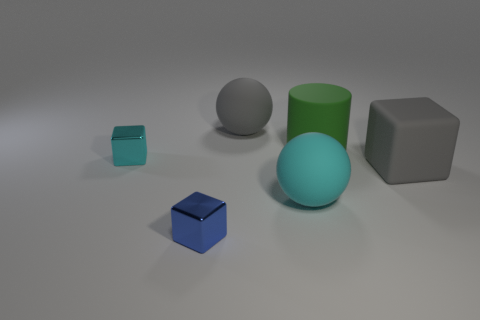Subtract all yellow cylinders. Subtract all red cubes. How many cylinders are left? 1 Subtract all blue cylinders. How many green balls are left? 0 Add 5 large things. How many blues exist? 0 Subtract all large cyan matte things. Subtract all big purple metal cylinders. How many objects are left? 5 Add 6 big green cylinders. How many big green cylinders are left? 7 Add 2 matte blocks. How many matte blocks exist? 3 Add 4 gray rubber balls. How many objects exist? 10 Subtract all cyan cubes. How many cubes are left? 2 Subtract all big cubes. How many cubes are left? 2 Subtract 1 gray balls. How many objects are left? 5 